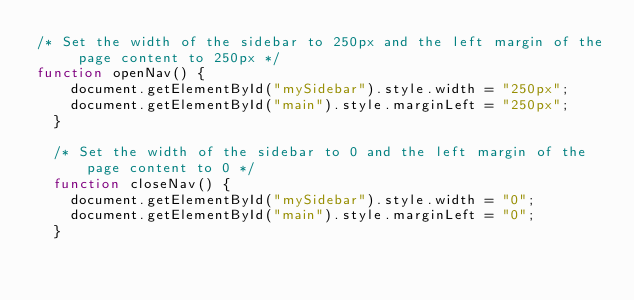<code> <loc_0><loc_0><loc_500><loc_500><_JavaScript_>/* Set the width of the sidebar to 250px and the left margin of the page content to 250px */
function openNav() {
    document.getElementById("mySidebar").style.width = "250px";
    document.getElementById("main").style.marginLeft = "250px";
  }

  /* Set the width of the sidebar to 0 and the left margin of the page content to 0 */
  function closeNav() {
    document.getElementById("mySidebar").style.width = "0";
    document.getElementById("main").style.marginLeft = "0";
  }
</code> 